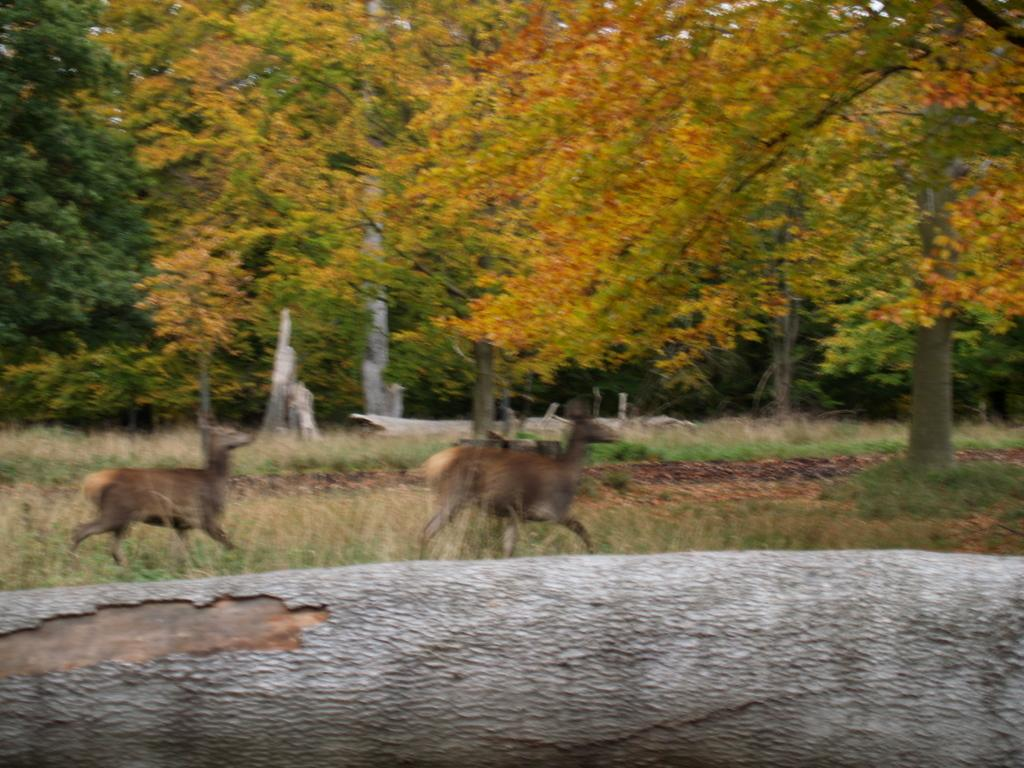What types of living organisms can be seen in the image? There are animals in the image. What can be seen in the background of the image? There are trees in the background of the image. What type of comb is being used by the animals in the image? There is no comb present in the image, as it features animals and trees in the background. 